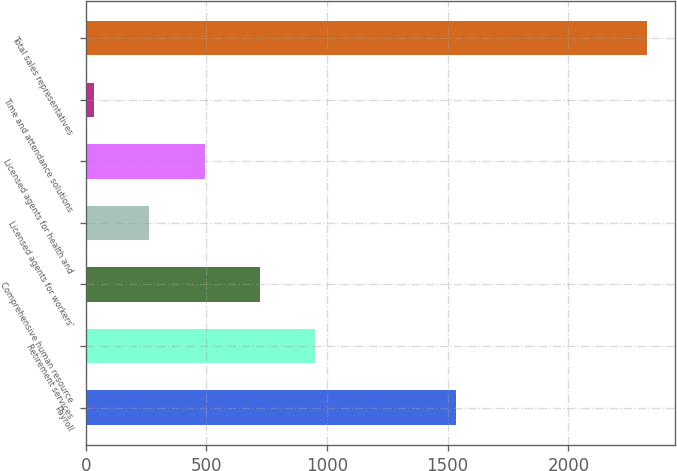<chart> <loc_0><loc_0><loc_500><loc_500><bar_chart><fcel>Payroll<fcel>Retirement services<fcel>Comprehensive human resource<fcel>Licensed agents for workers'<fcel>Licensed agents for health and<fcel>Time and attendance solutions<fcel>Total sales representatives<nl><fcel>1535<fcel>951<fcel>722<fcel>264<fcel>493<fcel>35<fcel>2325<nl></chart> 